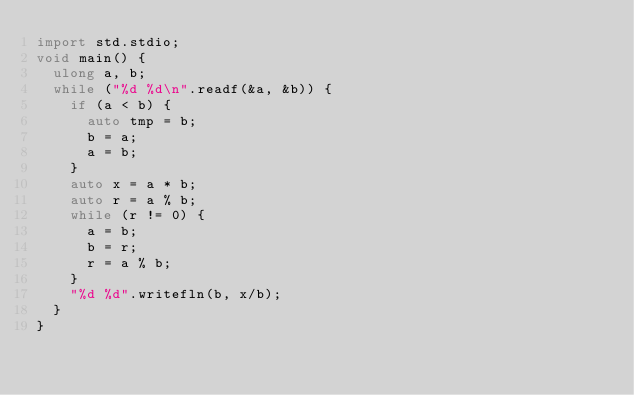<code> <loc_0><loc_0><loc_500><loc_500><_D_>import std.stdio;
void main() {
	ulong a, b;
	while ("%d %d\n".readf(&a, &b)) {
		if (a < b) {
			auto tmp = b;
			b = a;
			a = b;
		}
		auto x = a * b;
		auto r = a % b;
		while (r != 0) {
			a = b;
			b = r;
			r = a % b;
		}
		"%d %d".writefln(b, x/b);
	}
}</code> 